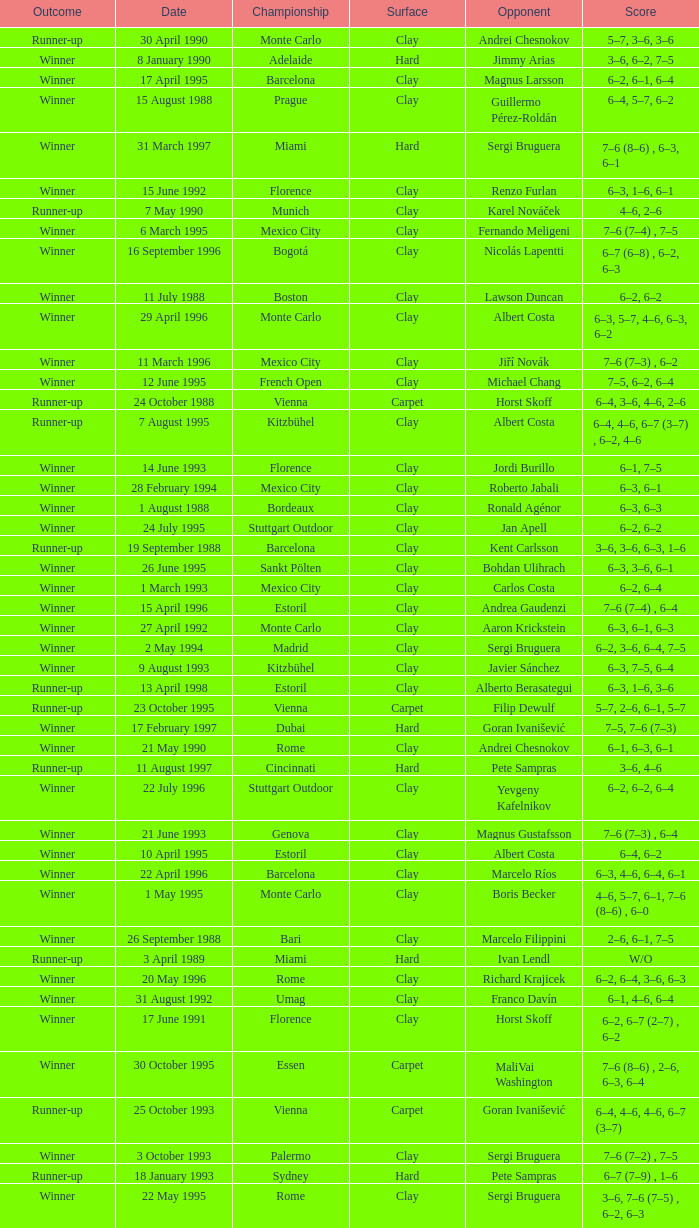What is the score when the championship is rome and the opponent is richard krajicek? 6–2, 6–4, 3–6, 6–3. 